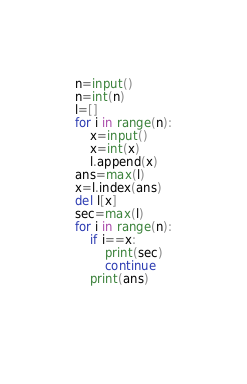<code> <loc_0><loc_0><loc_500><loc_500><_Python_>n=input()
n=int(n)
l=[]
for i in range(n):
    x=input()
    x=int(x)
    l.append(x)
ans=max(l)
x=l.index(ans)
del l[x]
sec=max(l)
for i in range(n):
    if i==x:
        print(sec)
        continue
    print(ans)
    
  
</code> 